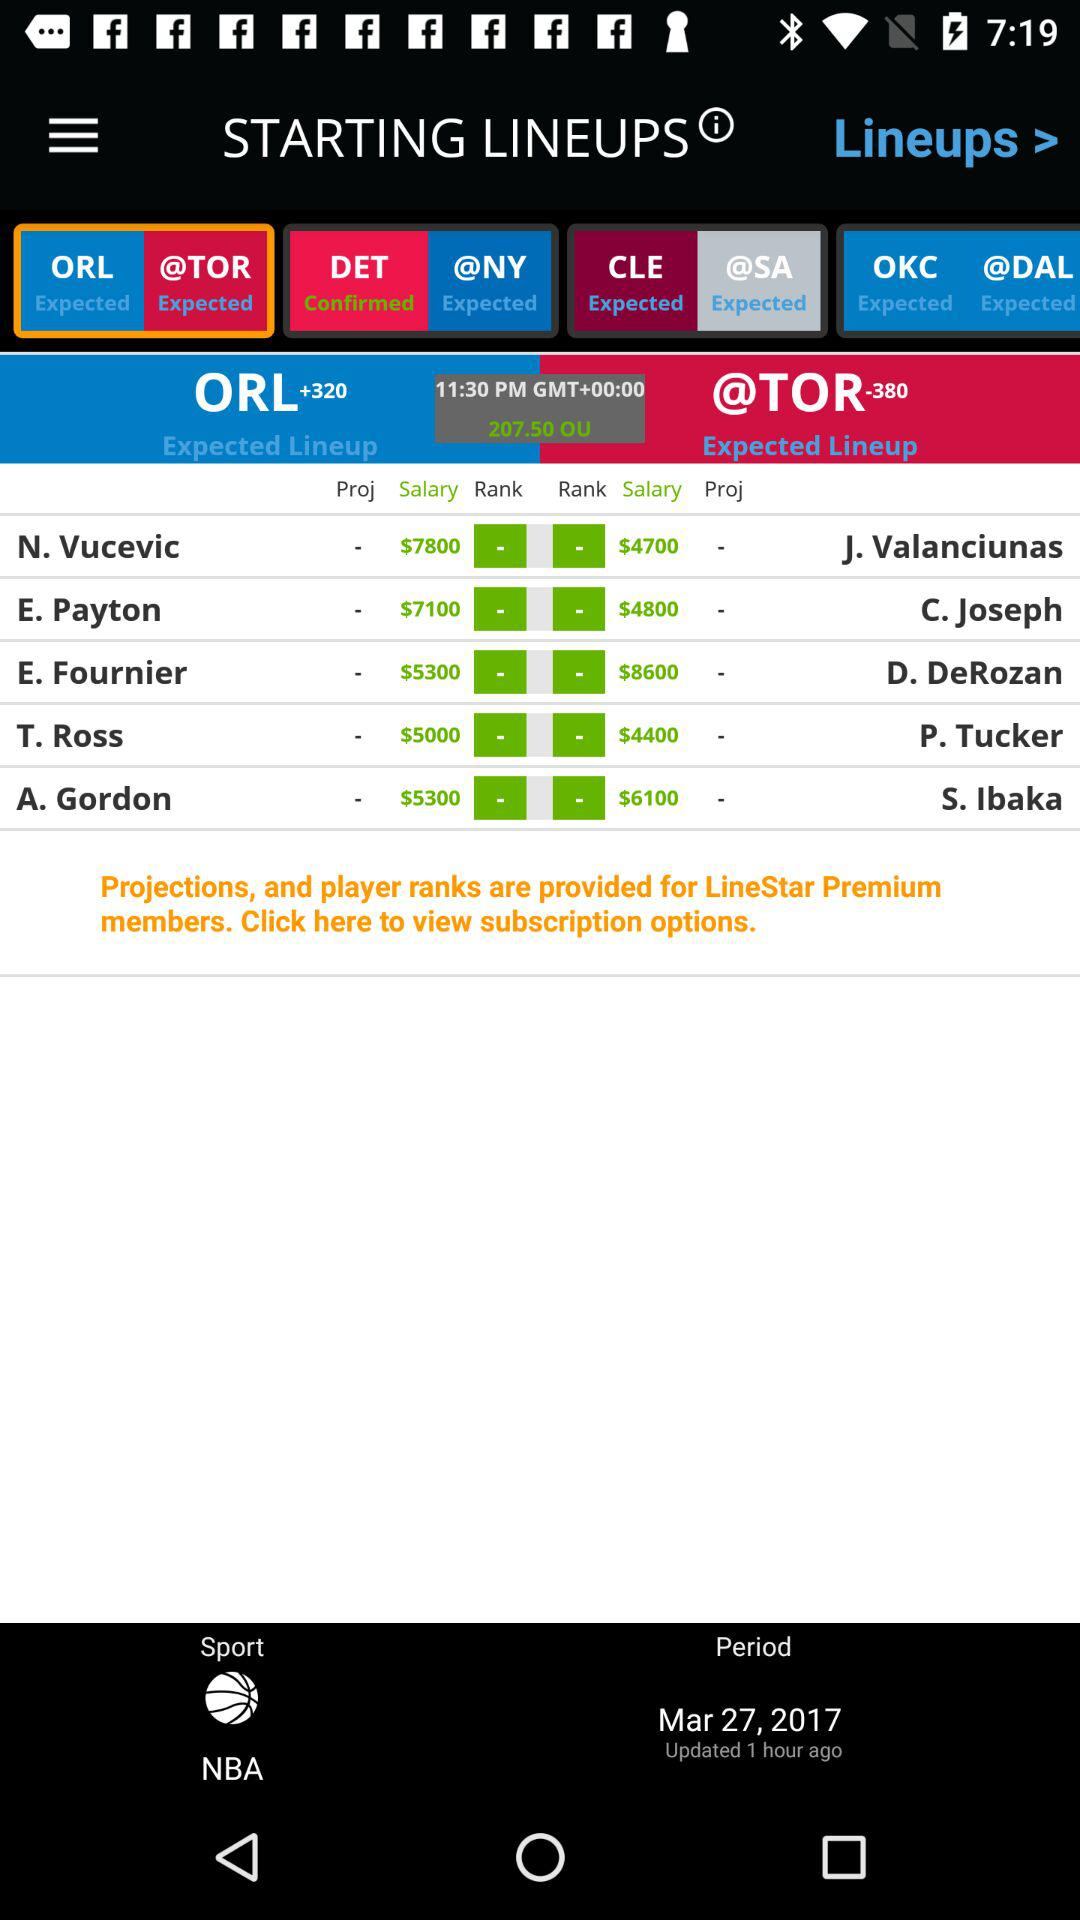What is the time? The time is 11:30 PM. 